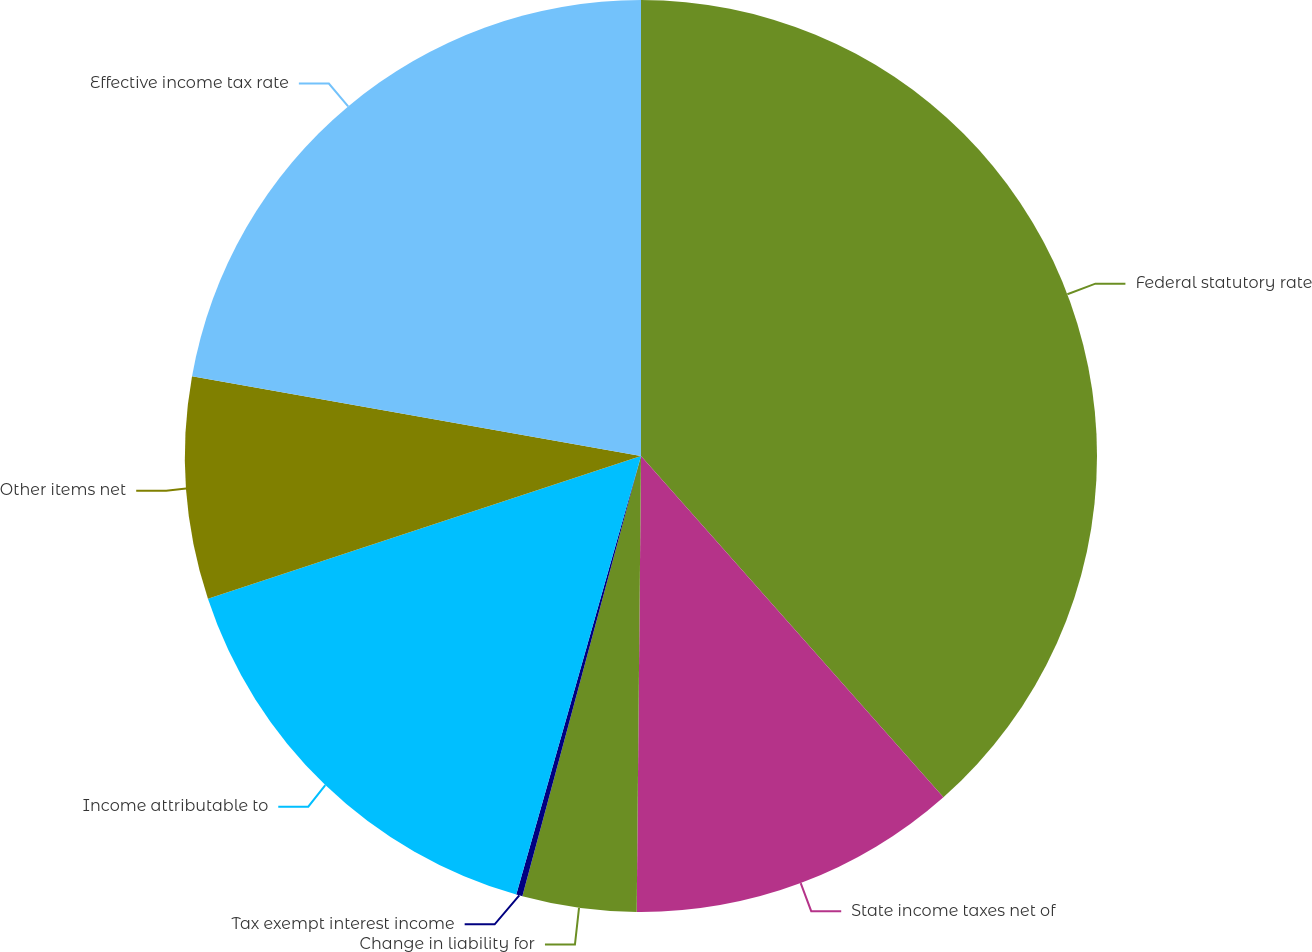<chart> <loc_0><loc_0><loc_500><loc_500><pie_chart><fcel>Federal statutory rate<fcel>State income taxes net of<fcel>Change in liability for<fcel>Tax exempt interest income<fcel>Income attributable to<fcel>Other items net<fcel>Effective income tax rate<nl><fcel>38.46%<fcel>11.69%<fcel>4.04%<fcel>0.22%<fcel>15.52%<fcel>7.87%<fcel>22.2%<nl></chart> 